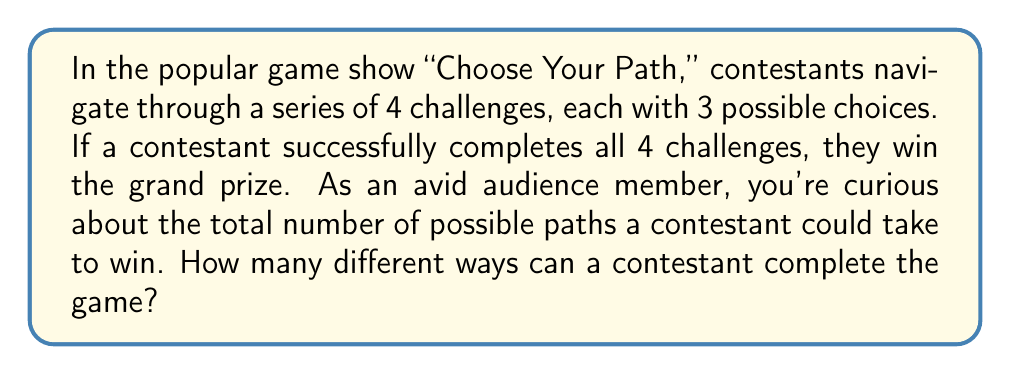Provide a solution to this math problem. Let's approach this step-by-step:

1) For each challenge, the contestant has 3 choices.

2) The contestant must make a choice for all 4 challenges.

3) This scenario follows the multiplication principle of counting. When we have a series of independent choices, we multiply the number of options for each choice.

4) In this case, we have:
   - 3 choices for the first challenge
   - 3 choices for the second challenge
   - 3 choices for the third challenge
   - 3 choices for the fourth challenge

5) Mathematically, this can be expressed as:

   $$3 \times 3 \times 3 \times 3 = 3^4$$

6) We can calculate this:

   $$3^4 = 3 \times 3 \times 3 \times 3 = 81$$

Therefore, there are 81 different possible paths a contestant could take to complete all 4 challenges and win the game.
Answer: $3^4 = 81$ 